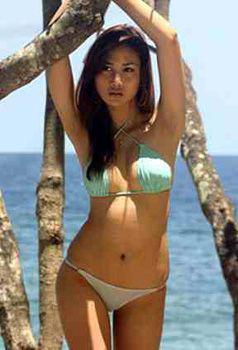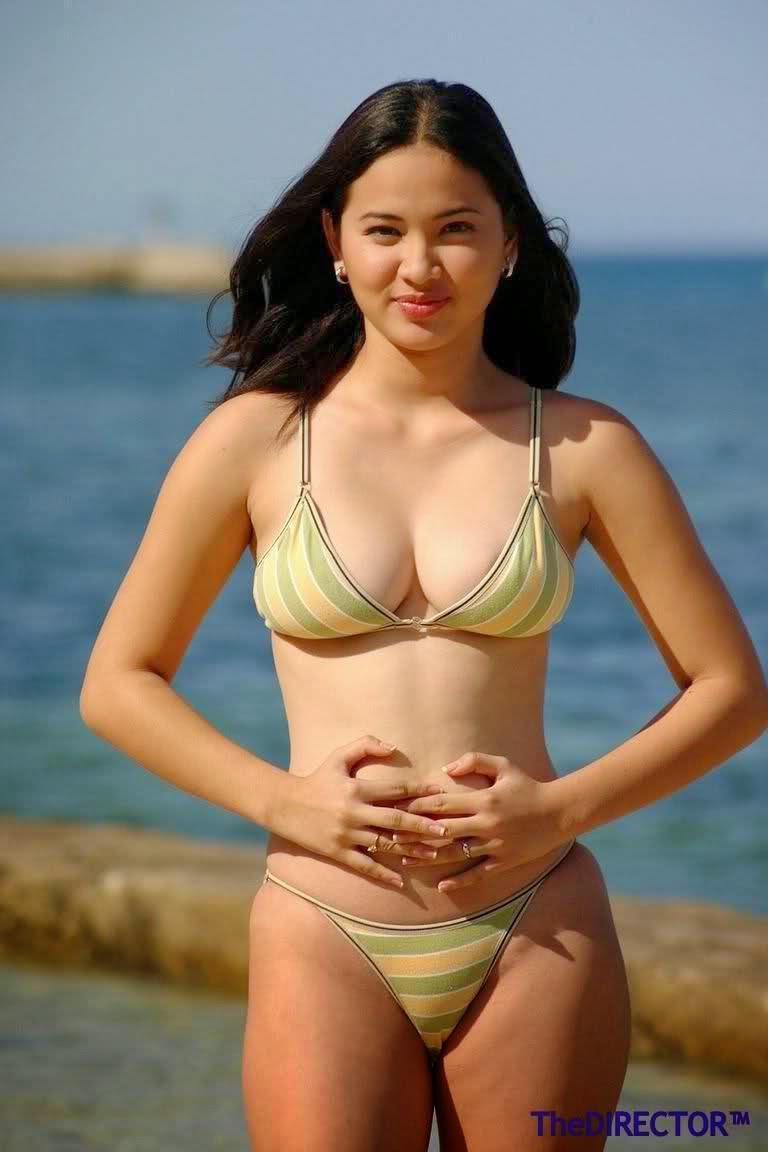The first image is the image on the left, the second image is the image on the right. Considering the images on both sides, is "There are an equal number of girls in both images." valid? Answer yes or no. Yes. The first image is the image on the left, the second image is the image on the right. Analyze the images presented: Is the assertion "The combined images contain four bikini models, and none have sunglasses covering their eyes." valid? Answer yes or no. No. 